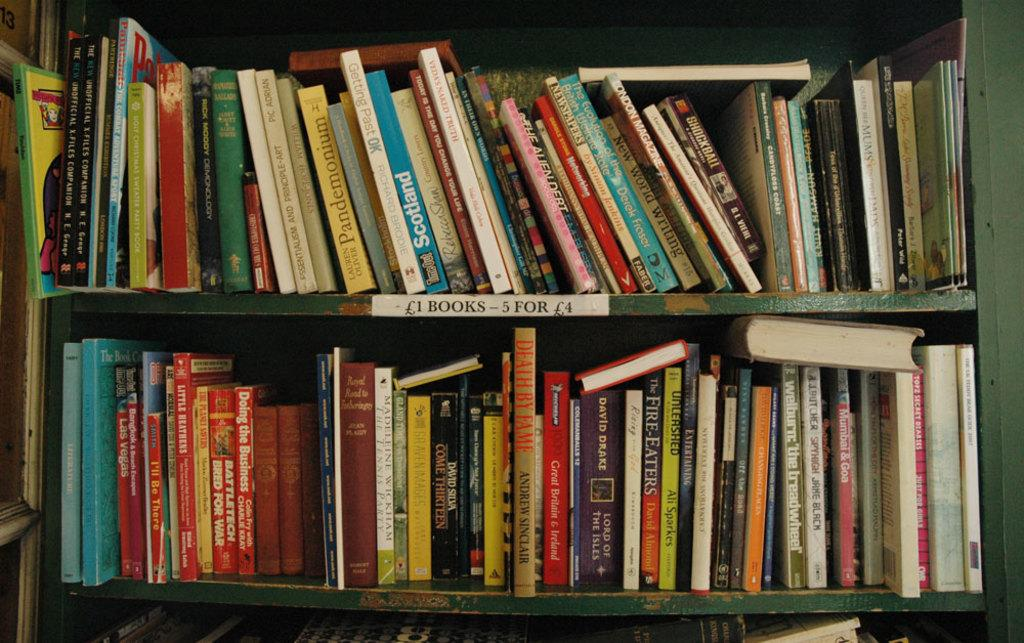<image>
Present a compact description of the photo's key features. A lot of books sit on a shift that says books are 5 for 4 pounds, or 1 pound each. 